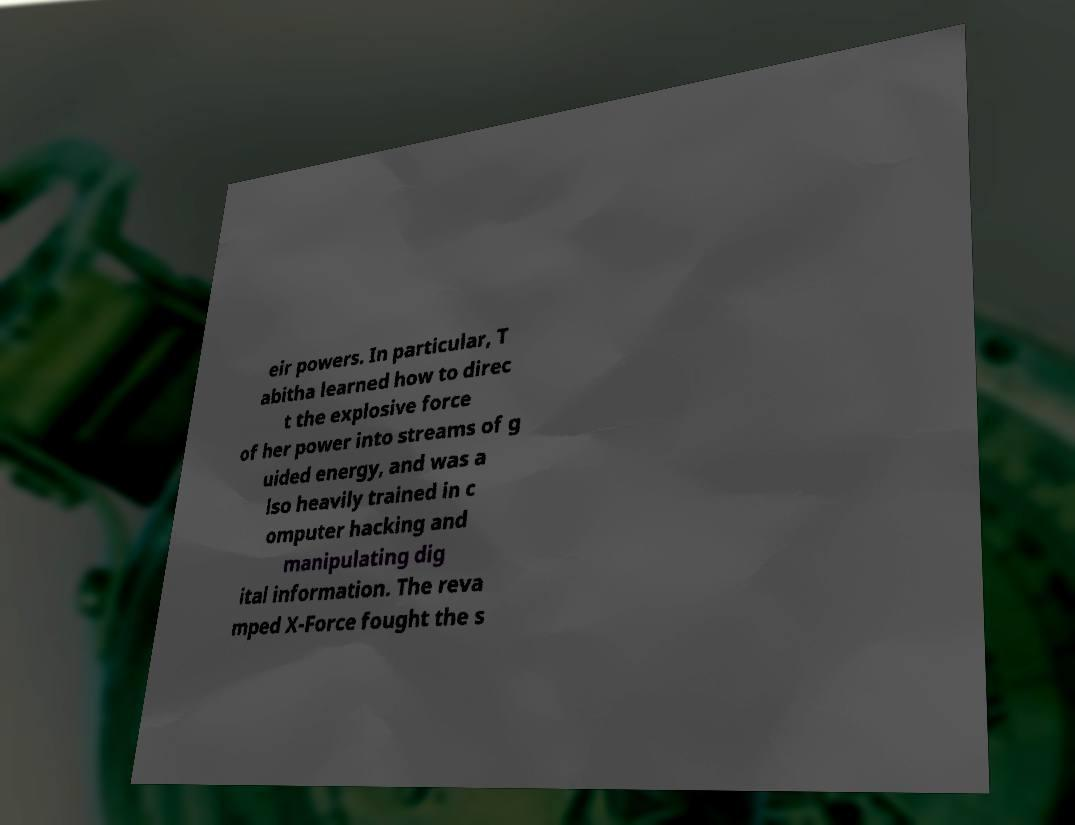There's text embedded in this image that I need extracted. Can you transcribe it verbatim? eir powers. In particular, T abitha learned how to direc t the explosive force of her power into streams of g uided energy, and was a lso heavily trained in c omputer hacking and manipulating dig ital information. The reva mped X-Force fought the s 